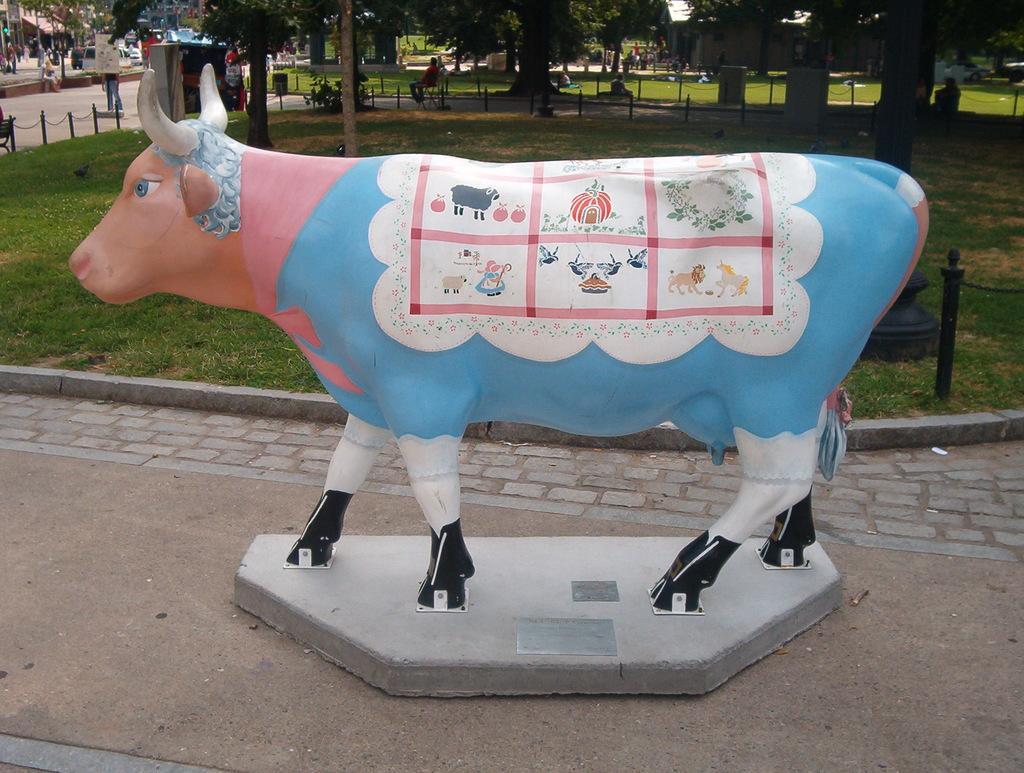Can you describe this image briefly? There is a statue of a cow with some images on that. In the background there are trees and many other things. On the ground there is grass. 